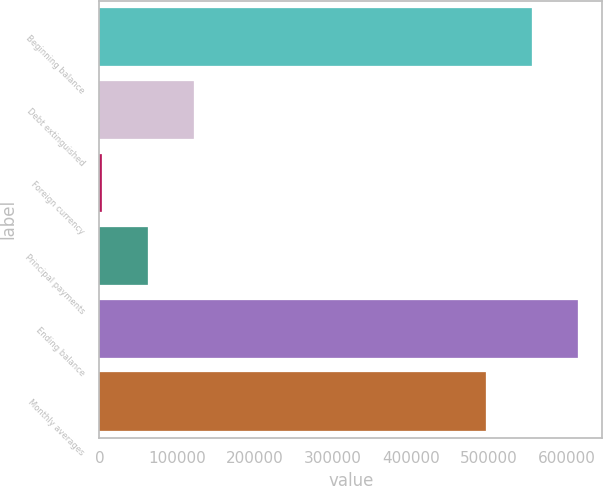Convert chart to OTSL. <chart><loc_0><loc_0><loc_500><loc_500><bar_chart><fcel>Beginning balance<fcel>Debt extinguished<fcel>Foreign currency<fcel>Principal payments<fcel>Ending balance<fcel>Monthly averages<nl><fcel>556317<fcel>121365<fcel>3157<fcel>62261.2<fcel>615421<fcel>497213<nl></chart> 